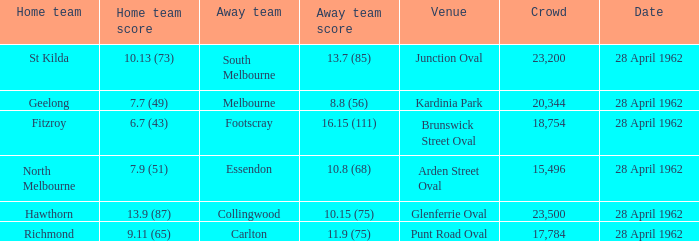In what place did an away team record 1 Glenferrie Oval. 